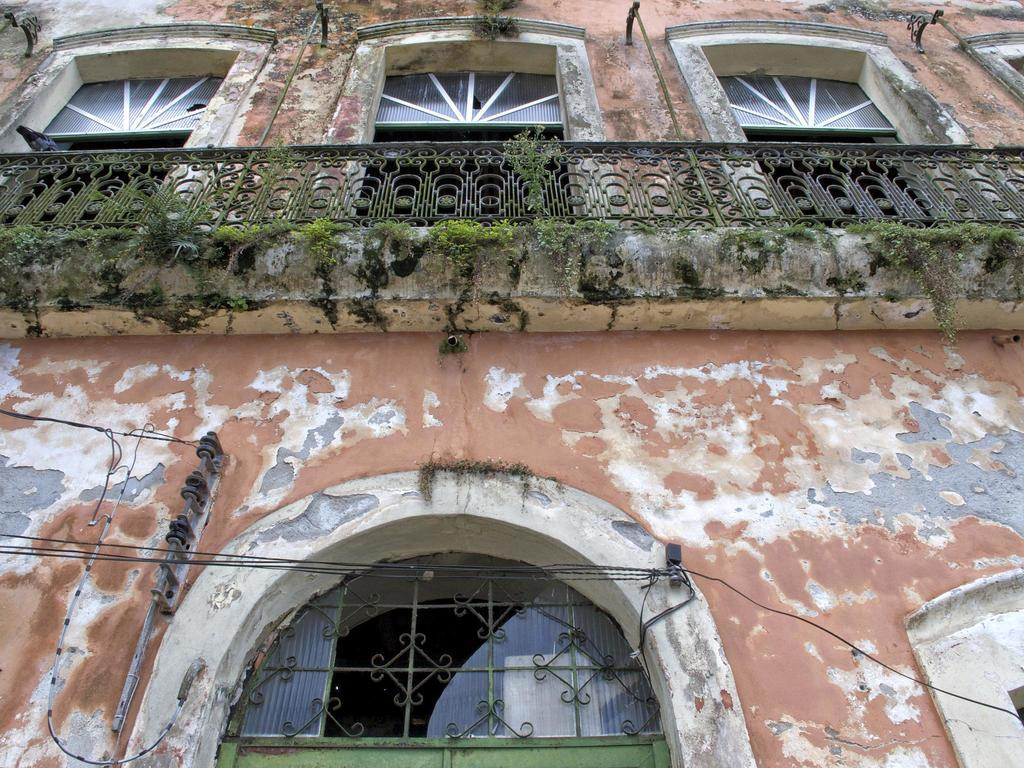What type of structure is visible in the image? There is a building in the image. Can you describe the appearance of the building? The paint on the building is fading. What feature of the building is mentioned in the facts? There are visible in the image? What type of vegetation can be seen on the balcony of the building? There is grass on the balcony of the building. What is the average income of the people living in the building in the image? There is no information about the income of the people living in the building in the image. How many oranges are visible on the balcony of the building? There are no oranges present in the image. 